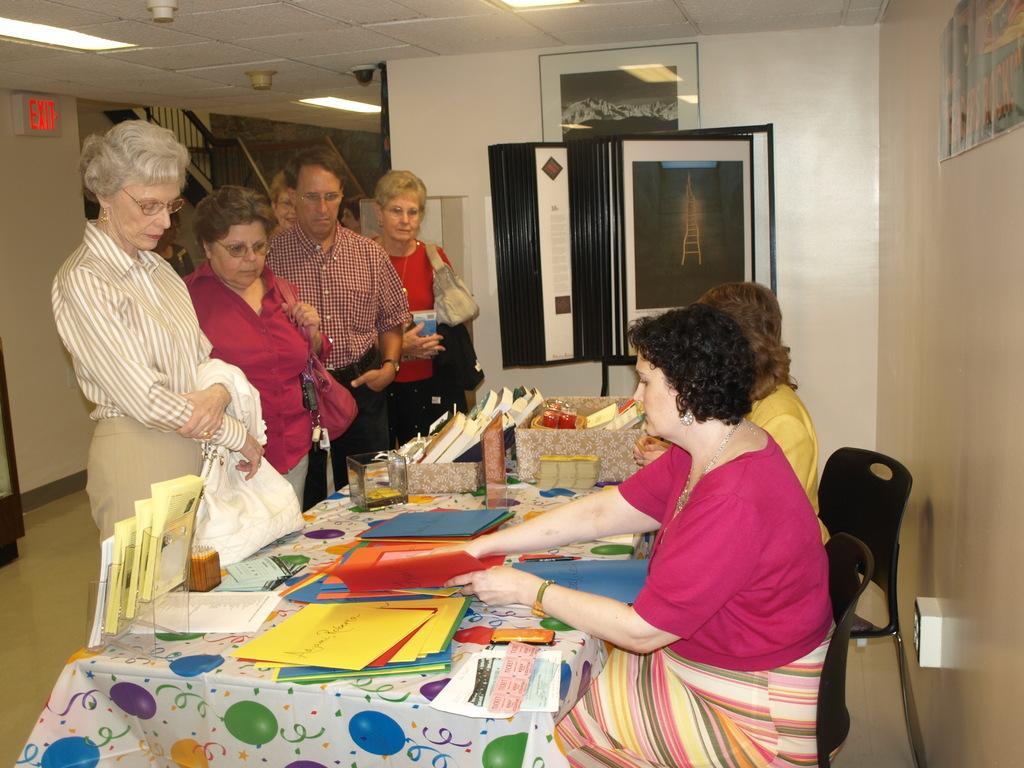Could you give a brief overview of what you see in this image? This picture shows people standing and watching few color papers on the table. two women seated on the chair and showing the papers to people 